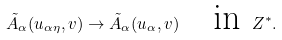<formula> <loc_0><loc_0><loc_500><loc_500>\tilde { A } _ { \alpha } ( u _ { \alpha \eta } , v ) \to \tilde { A } _ { \alpha } ( u _ { \alpha } , v ) \quad \text {in } Z ^ { * } .</formula> 